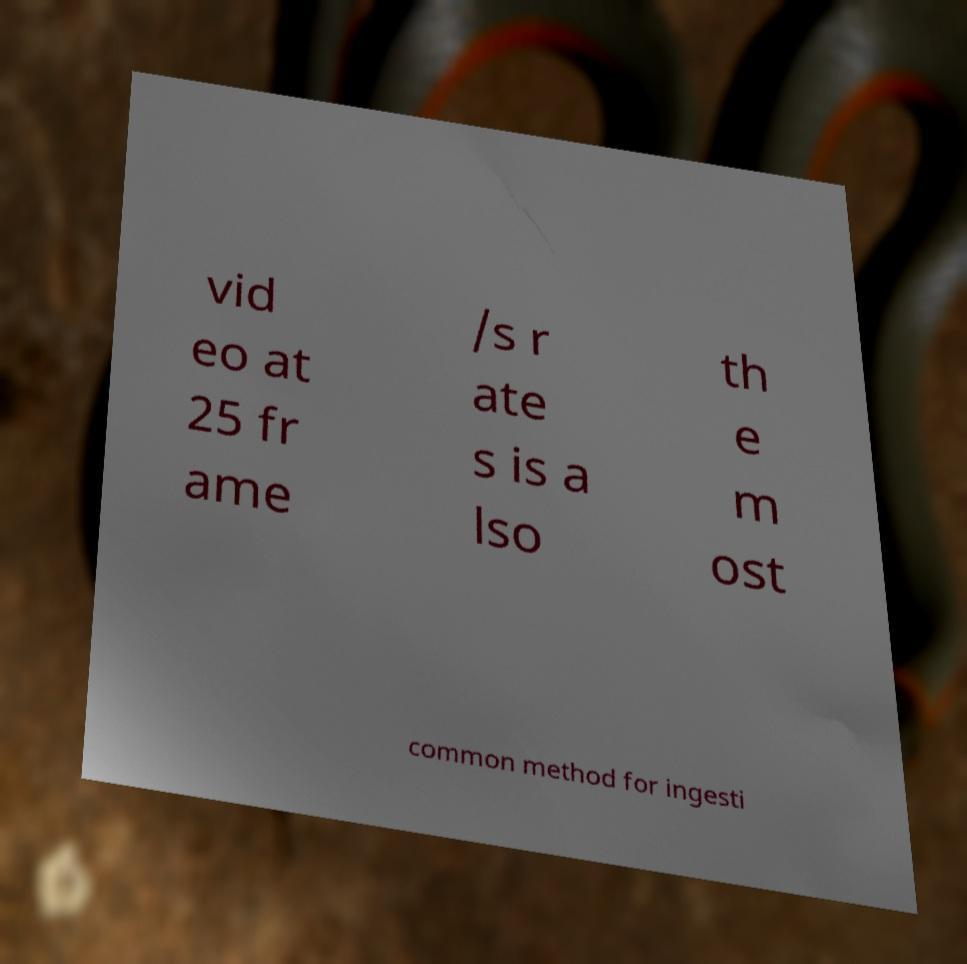Please identify and transcribe the text found in this image. vid eo at 25 fr ame /s r ate s is a lso th e m ost common method for ingesti 